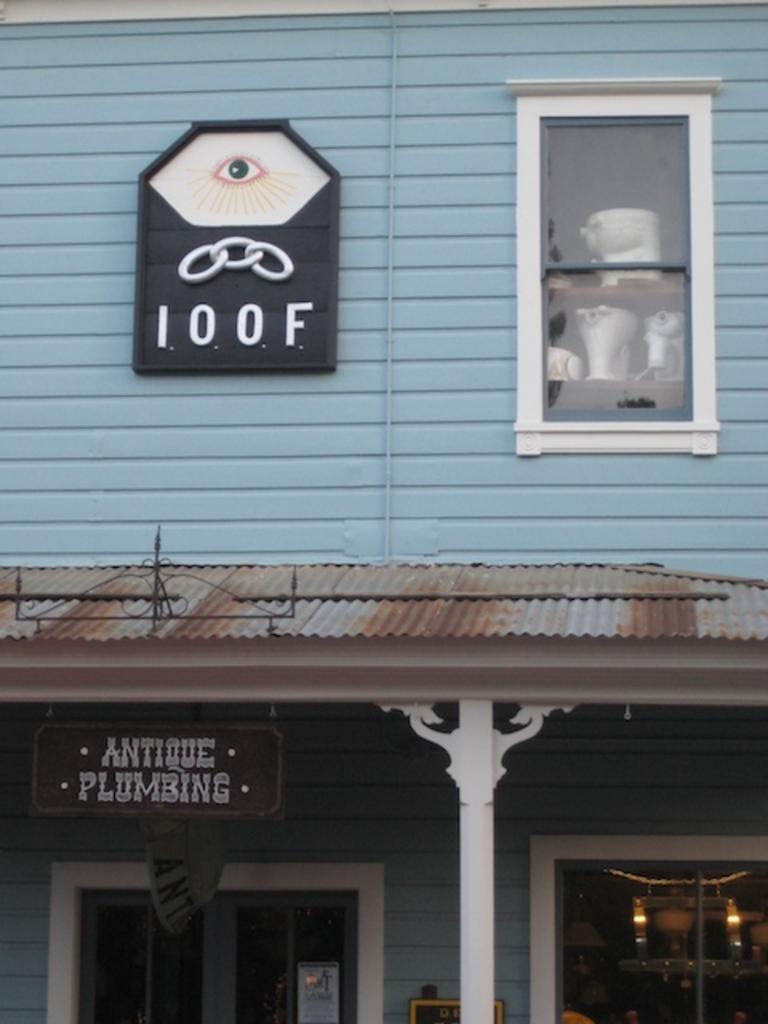What body part symbol of on the loof board?
Provide a short and direct response. Eye. 